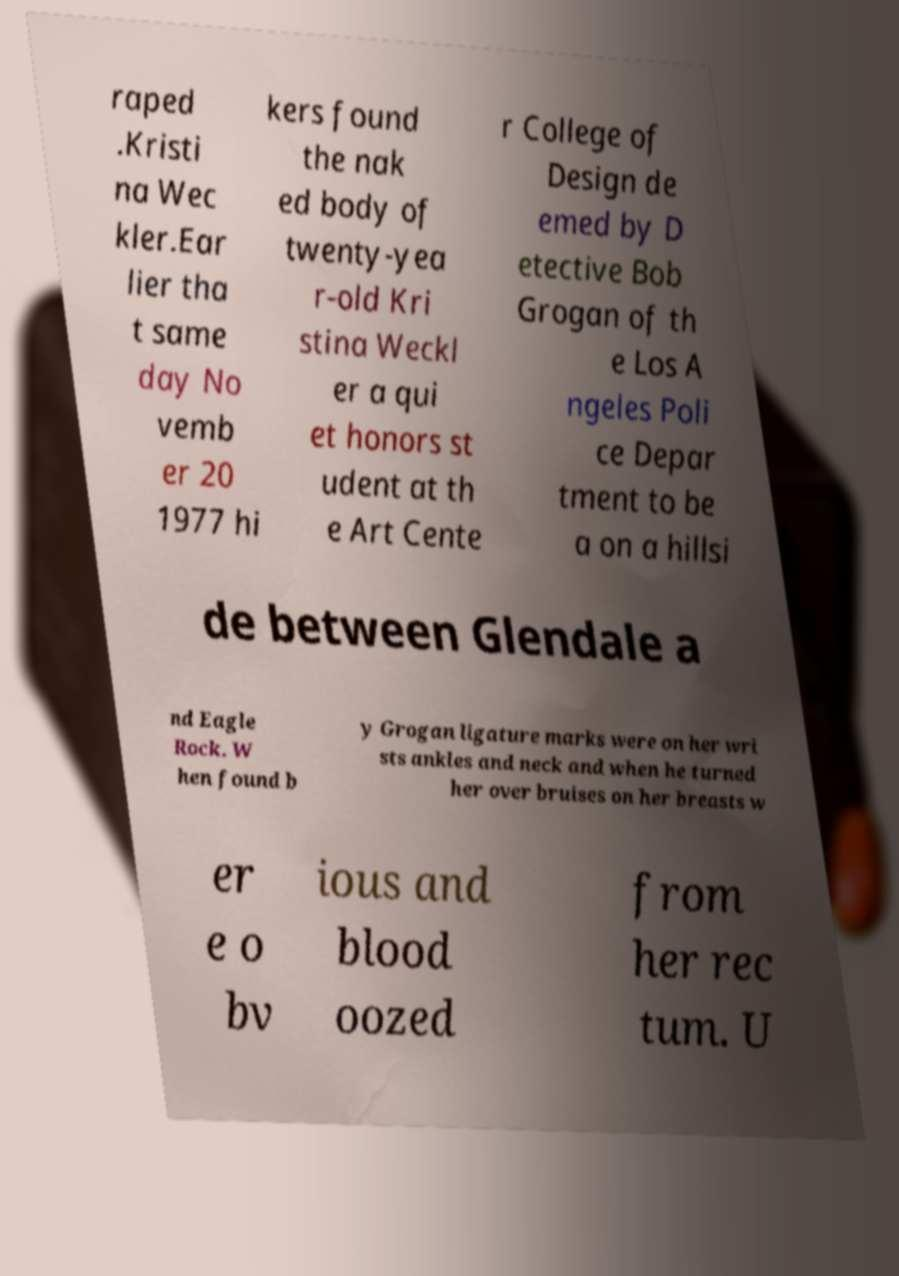Can you accurately transcribe the text from the provided image for me? raped .Kristi na Wec kler.Ear lier tha t same day No vemb er 20 1977 hi kers found the nak ed body of twenty-yea r-old Kri stina Weckl er a qui et honors st udent at th e Art Cente r College of Design de emed by D etective Bob Grogan of th e Los A ngeles Poli ce Depar tment to be a on a hillsi de between Glendale a nd Eagle Rock. W hen found b y Grogan ligature marks were on her wri sts ankles and neck and when he turned her over bruises on her breasts w er e o bv ious and blood oozed from her rec tum. U 